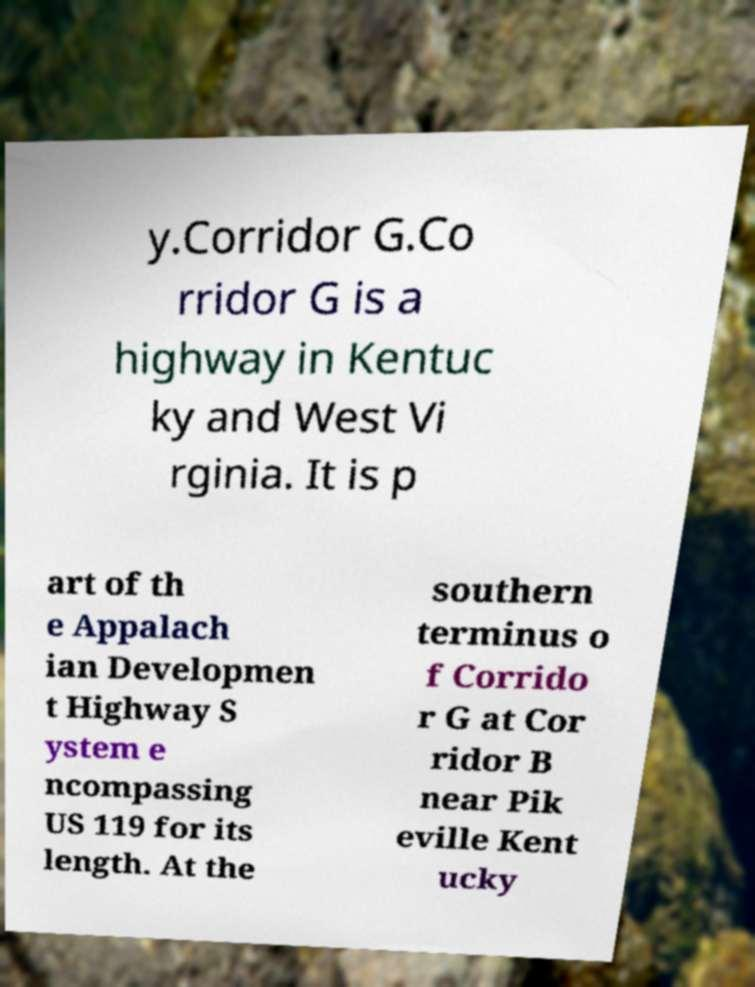Please read and relay the text visible in this image. What does it say? y.Corridor G.Co rridor G is a highway in Kentuc ky and West Vi rginia. It is p art of th e Appalach ian Developmen t Highway S ystem e ncompassing US 119 for its length. At the southern terminus o f Corrido r G at Cor ridor B near Pik eville Kent ucky 